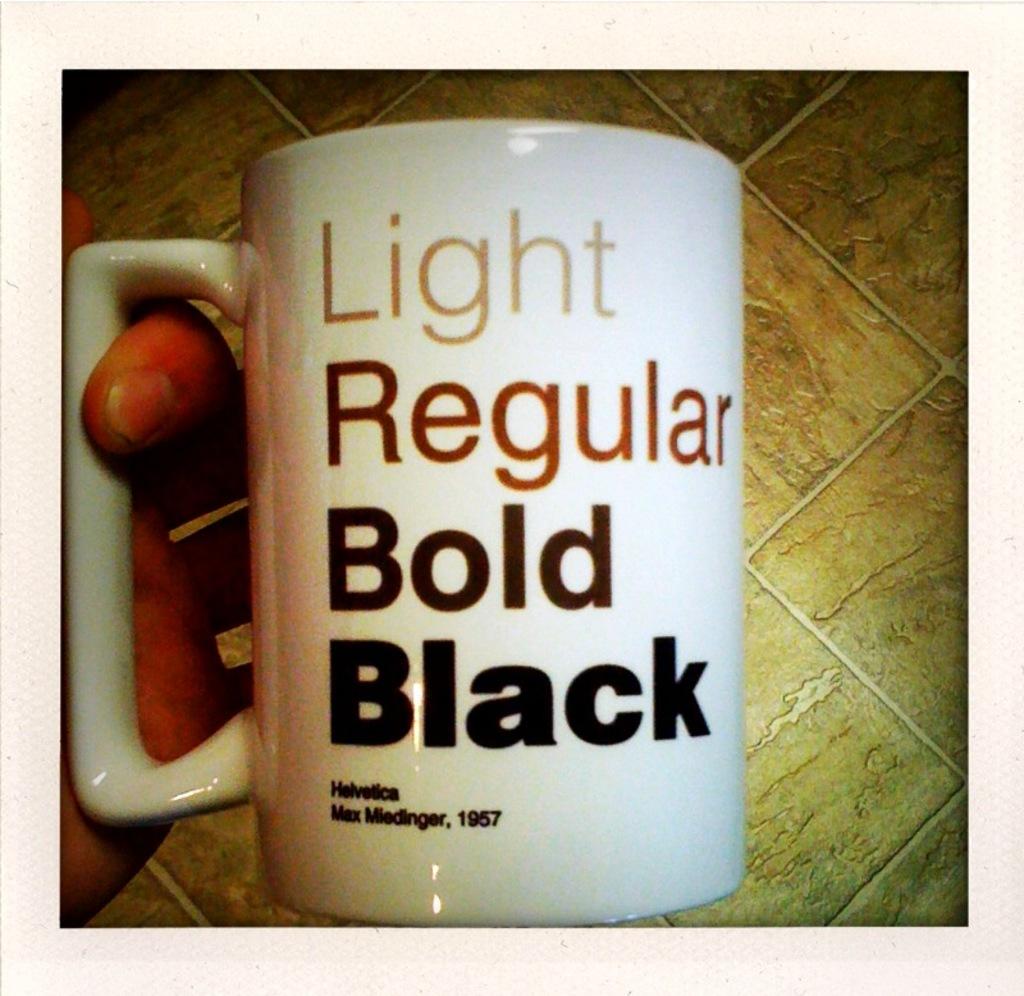What is written under bold?
Provide a succinct answer. Black. What is the date on the cup?
Make the answer very short. 1957. 